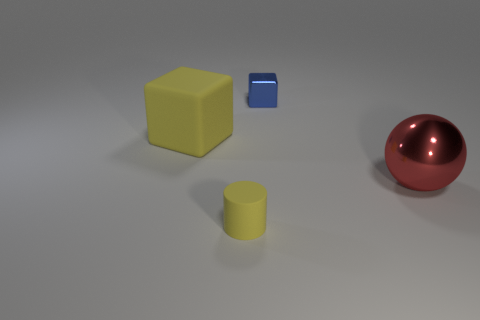Add 3 big rubber cylinders. How many objects exist? 7 Subtract all cylinders. How many objects are left? 3 Subtract 1 blocks. How many blocks are left? 1 Subtract all gray spheres. Subtract all gray cylinders. How many spheres are left? 1 Subtract all cyan cylinders. How many yellow cubes are left? 1 Subtract all big yellow rubber cubes. Subtract all small red rubber objects. How many objects are left? 3 Add 1 red metal spheres. How many red metal spheres are left? 2 Add 4 yellow rubber blocks. How many yellow rubber blocks exist? 5 Subtract 0 red cubes. How many objects are left? 4 